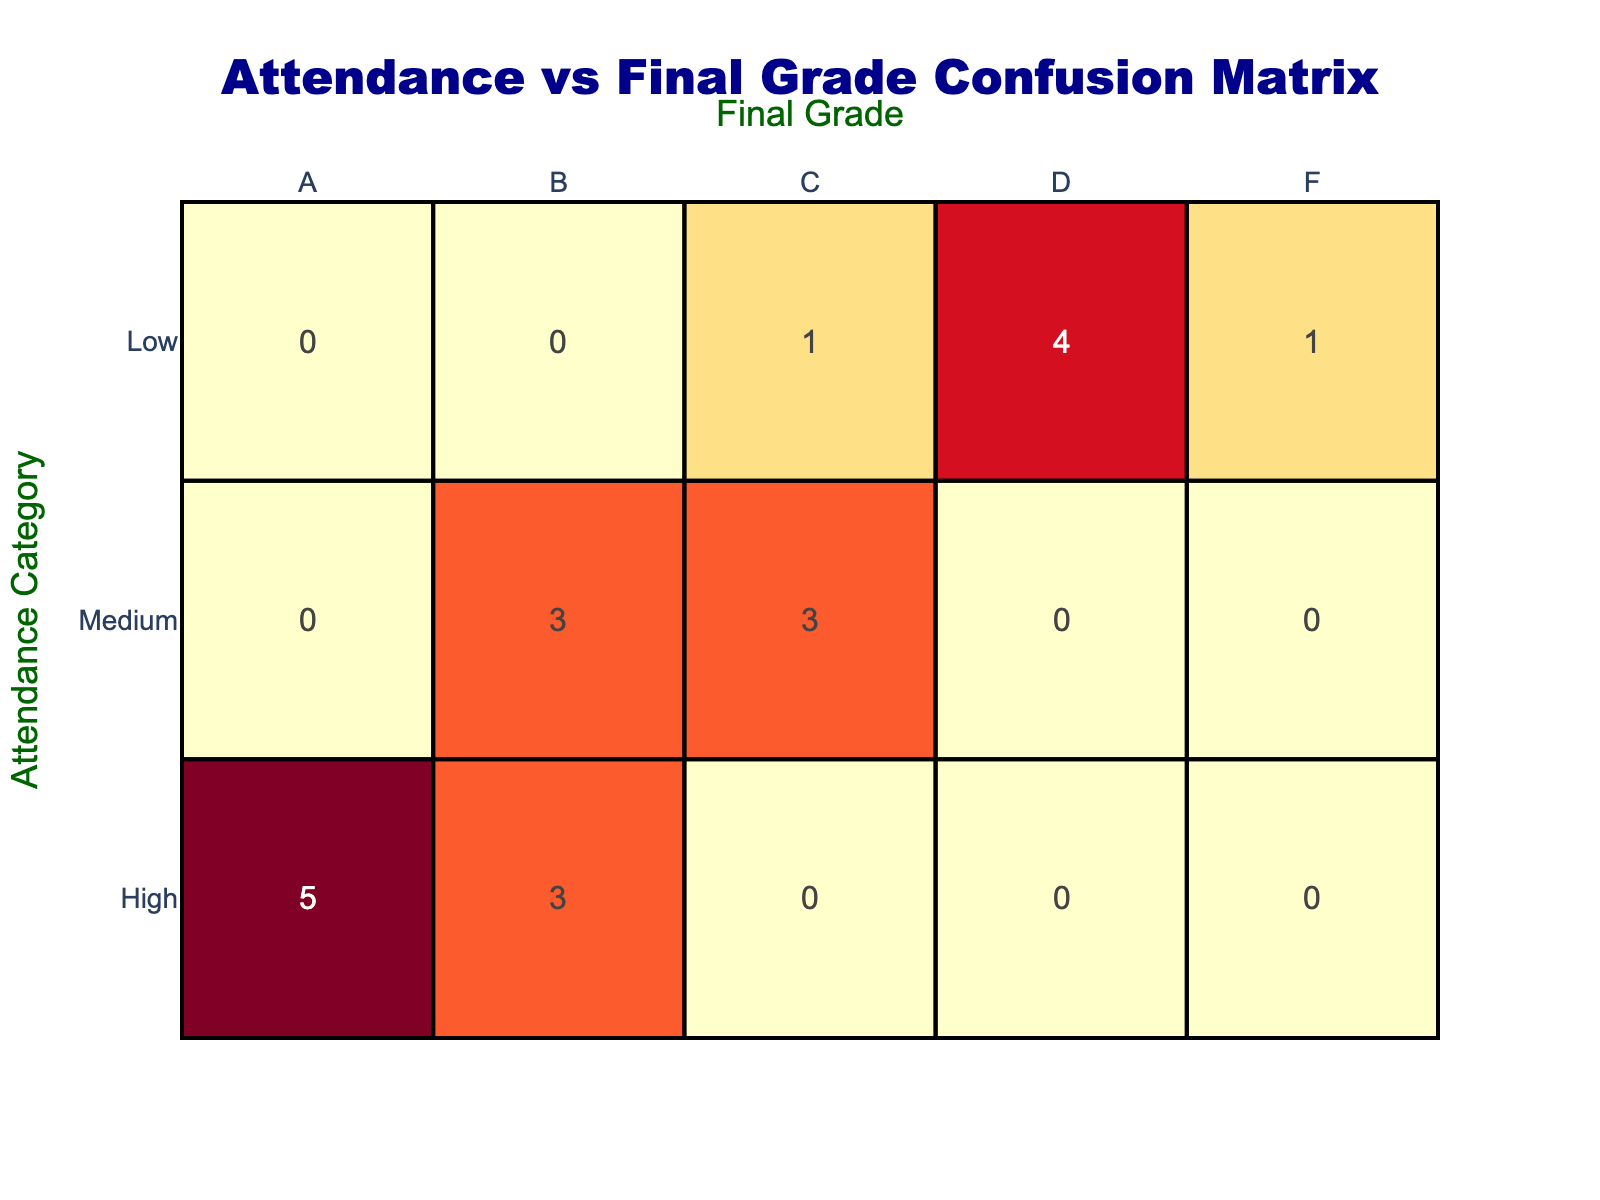What is the total number of students with High attendance? From the table, we can look at the row for "High" attendance and count the number of occurrences. There are 7 entries for High attendance (A: 4, B: 3, total = 4 + 3 = 7).
Answer: 7 How many students received a Final Grade of D? We need to check the "D" column across all attendance categories. There are 4 entries for Final Grade D (Low: 3, Medium: 1, so total = 3 + 1 = 4).
Answer: 4 What is the total number of students who had Low attendance and received a Final Grade of F? Looking at the "Low" row, we can see it indicates only 1 student received an F grade (F: 1).
Answer: 1 What percentage of High attendance students received A grades? We first identify that there are 7 students in High attendance and 4 of them received A grades. The percentage is calculated as (4/7)*100 = 57.14%.
Answer: 57.14% Is it true that all students with Low attendance received grades below C? Reviewing the "Low" row, we can identify that all three grades (C, D, F) are indeed below C, confirming the statement to be true.
Answer: True What is the average Final Grade for students with Medium attendance? From the table for Medium attendance, we have the grades B (2), C (3). We're using a numerical value for grading: A=4, B=3, C=2. (3*2 + 2*3) / 5 = 2.6.
Answer: 2.6 How many students with High attendance received grades that were not A? From the High row (A: 4, B: 3), we see that 3 students received grades that were not A (those who received B).
Answer: 3 What is the relationship between students with Low attendance and their grades? All students in the Low attendance category have grades lower than C (C, D, F). This shows that Low attendance negatively correlates with higher final grades.
Answer: Negative correlation What is the total number of students across all attendance categories who received a grade of B? We can count B grades from each category: High (3), Medium (2), Low (0). Totaling those amounts, we have 3 from High and 2 from Medium; thus, we have 5 students in total receiving a B.
Answer: 5 